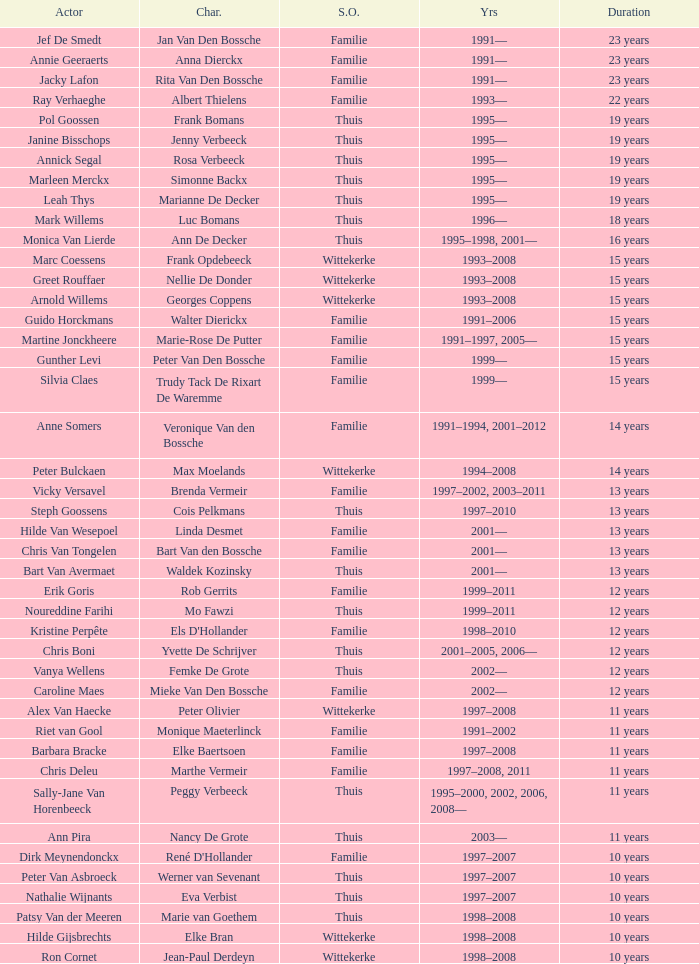What actor plays Marie-Rose De Putter? Martine Jonckheere. 